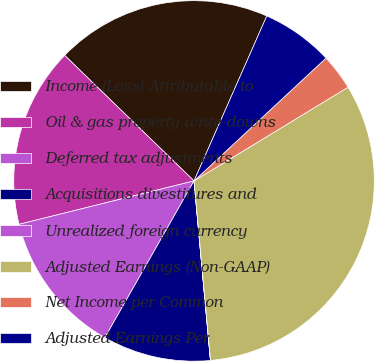Convert chart to OTSL. <chart><loc_0><loc_0><loc_500><loc_500><pie_chart><fcel>Income (Loss) Attributable to<fcel>Oil & gas property write-downs<fcel>Deferred tax adjustments<fcel>Acquisitions divestitures and<fcel>Unrealized foreign currency<fcel>Adjusted Earnings (Non-GAAP)<fcel>Net Income per Common<fcel>Adjusted Earnings Per<nl><fcel>19.35%<fcel>16.13%<fcel>12.9%<fcel>9.68%<fcel>0.01%<fcel>32.24%<fcel>3.23%<fcel>6.46%<nl></chart> 